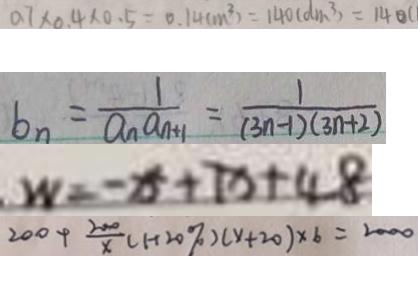<formula> <loc_0><loc_0><loc_500><loc_500>0 . 7 \times 0 . 4 \times 0 . 5 = 0 . 1 4 ( m ^ { 3 } ) = 1 4 0 ( d m ^ { 3 } ) = 1 4 0 ( d m ^ { 3 } ) = 1 4 ( m ^ { 3 } ) = 1 4 0 ( d m ^ { 3 } ) = 1 4 0 c 
 b _ { n } = \frac { 1 } { a _ { n } a _ { n + 1 } } = \frac { 1 } { ( 3 n - 1 ) ( 3 n + 2 ) } 
 W = - x + 7 x + 4 8 
 2 0 0 + \frac { 2 0 0 } { x } ( 1 + 2 0 \% ) ( x + 2 0 ) \times 6 = 2 0 0 0</formula> 